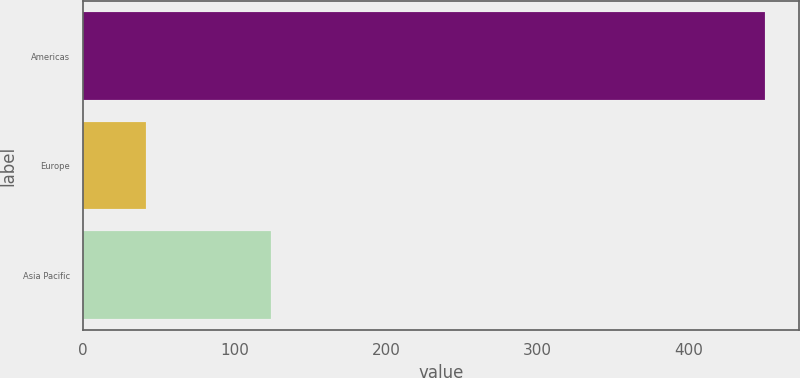<chart> <loc_0><loc_0><loc_500><loc_500><bar_chart><fcel>Americas<fcel>Europe<fcel>Asia Pacific<nl><fcel>450.2<fcel>41.4<fcel>124.3<nl></chart> 